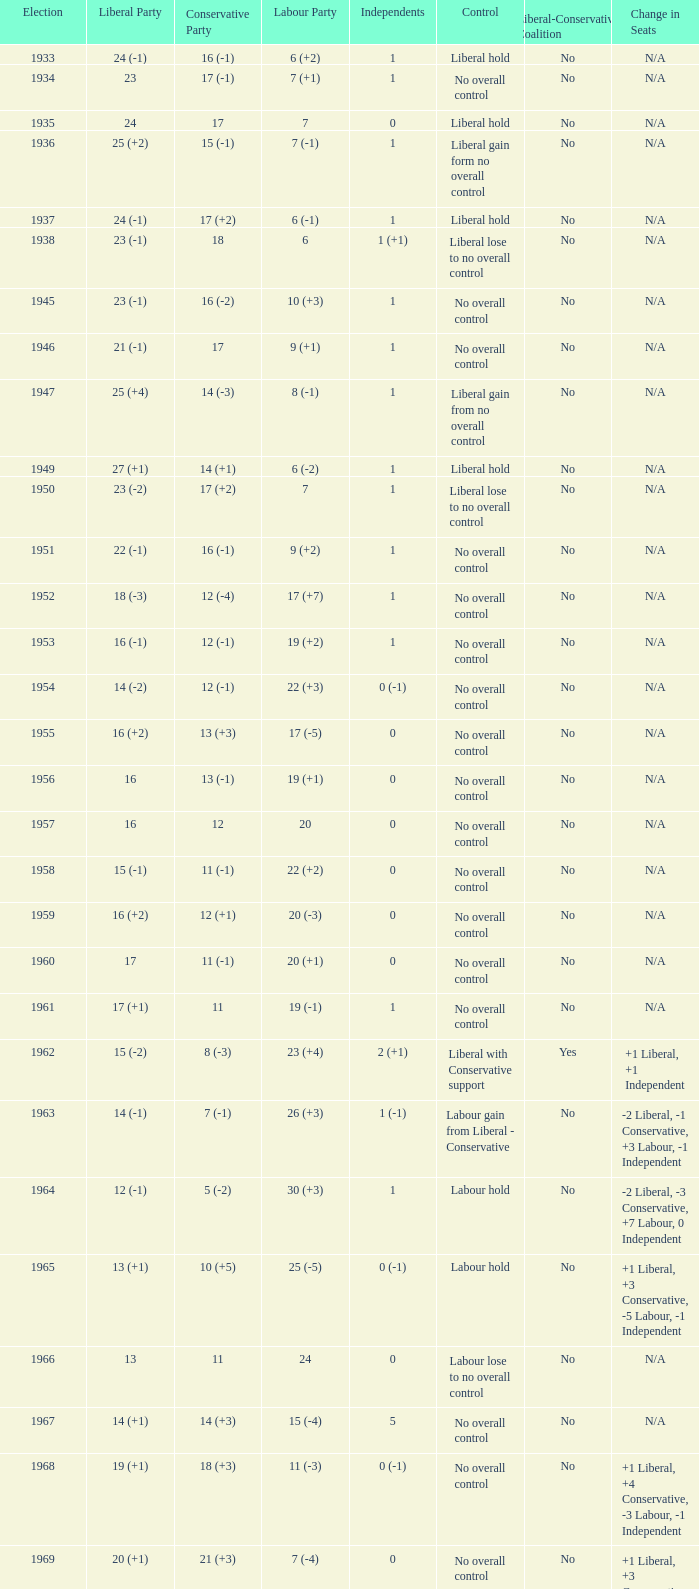What is the number of Independents elected in the year Labour won 26 (+3) seats? 1 (-1). 